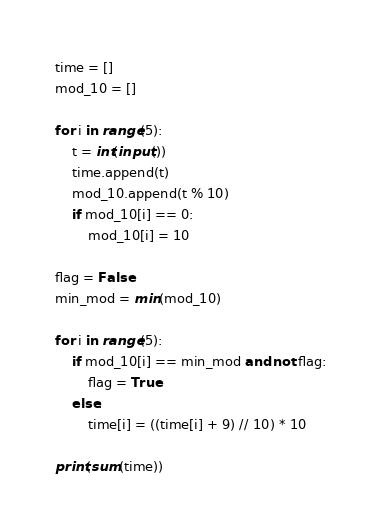<code> <loc_0><loc_0><loc_500><loc_500><_Python_>time = []
mod_10 = []

for i in range(5):
    t = int(input())
    time.append(t)
    mod_10.append(t % 10)
    if mod_10[i] == 0:
        mod_10[i] = 10

flag = False
min_mod = min(mod_10)

for i in range(5):
    if mod_10[i] == min_mod and not flag:
        flag = True
    else:
        time[i] = ((time[i] + 9) // 10) * 10

print(sum(time))</code> 